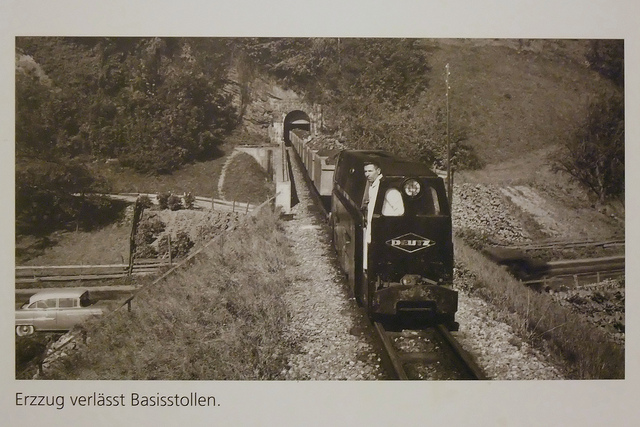<image>What language is this photo captioned with? I am not sure what language the photo is captioned with. It can be either German or Italian. What language is this photo captioned with? I don't know what language is this photo captioned with. It can be German or Italian. 